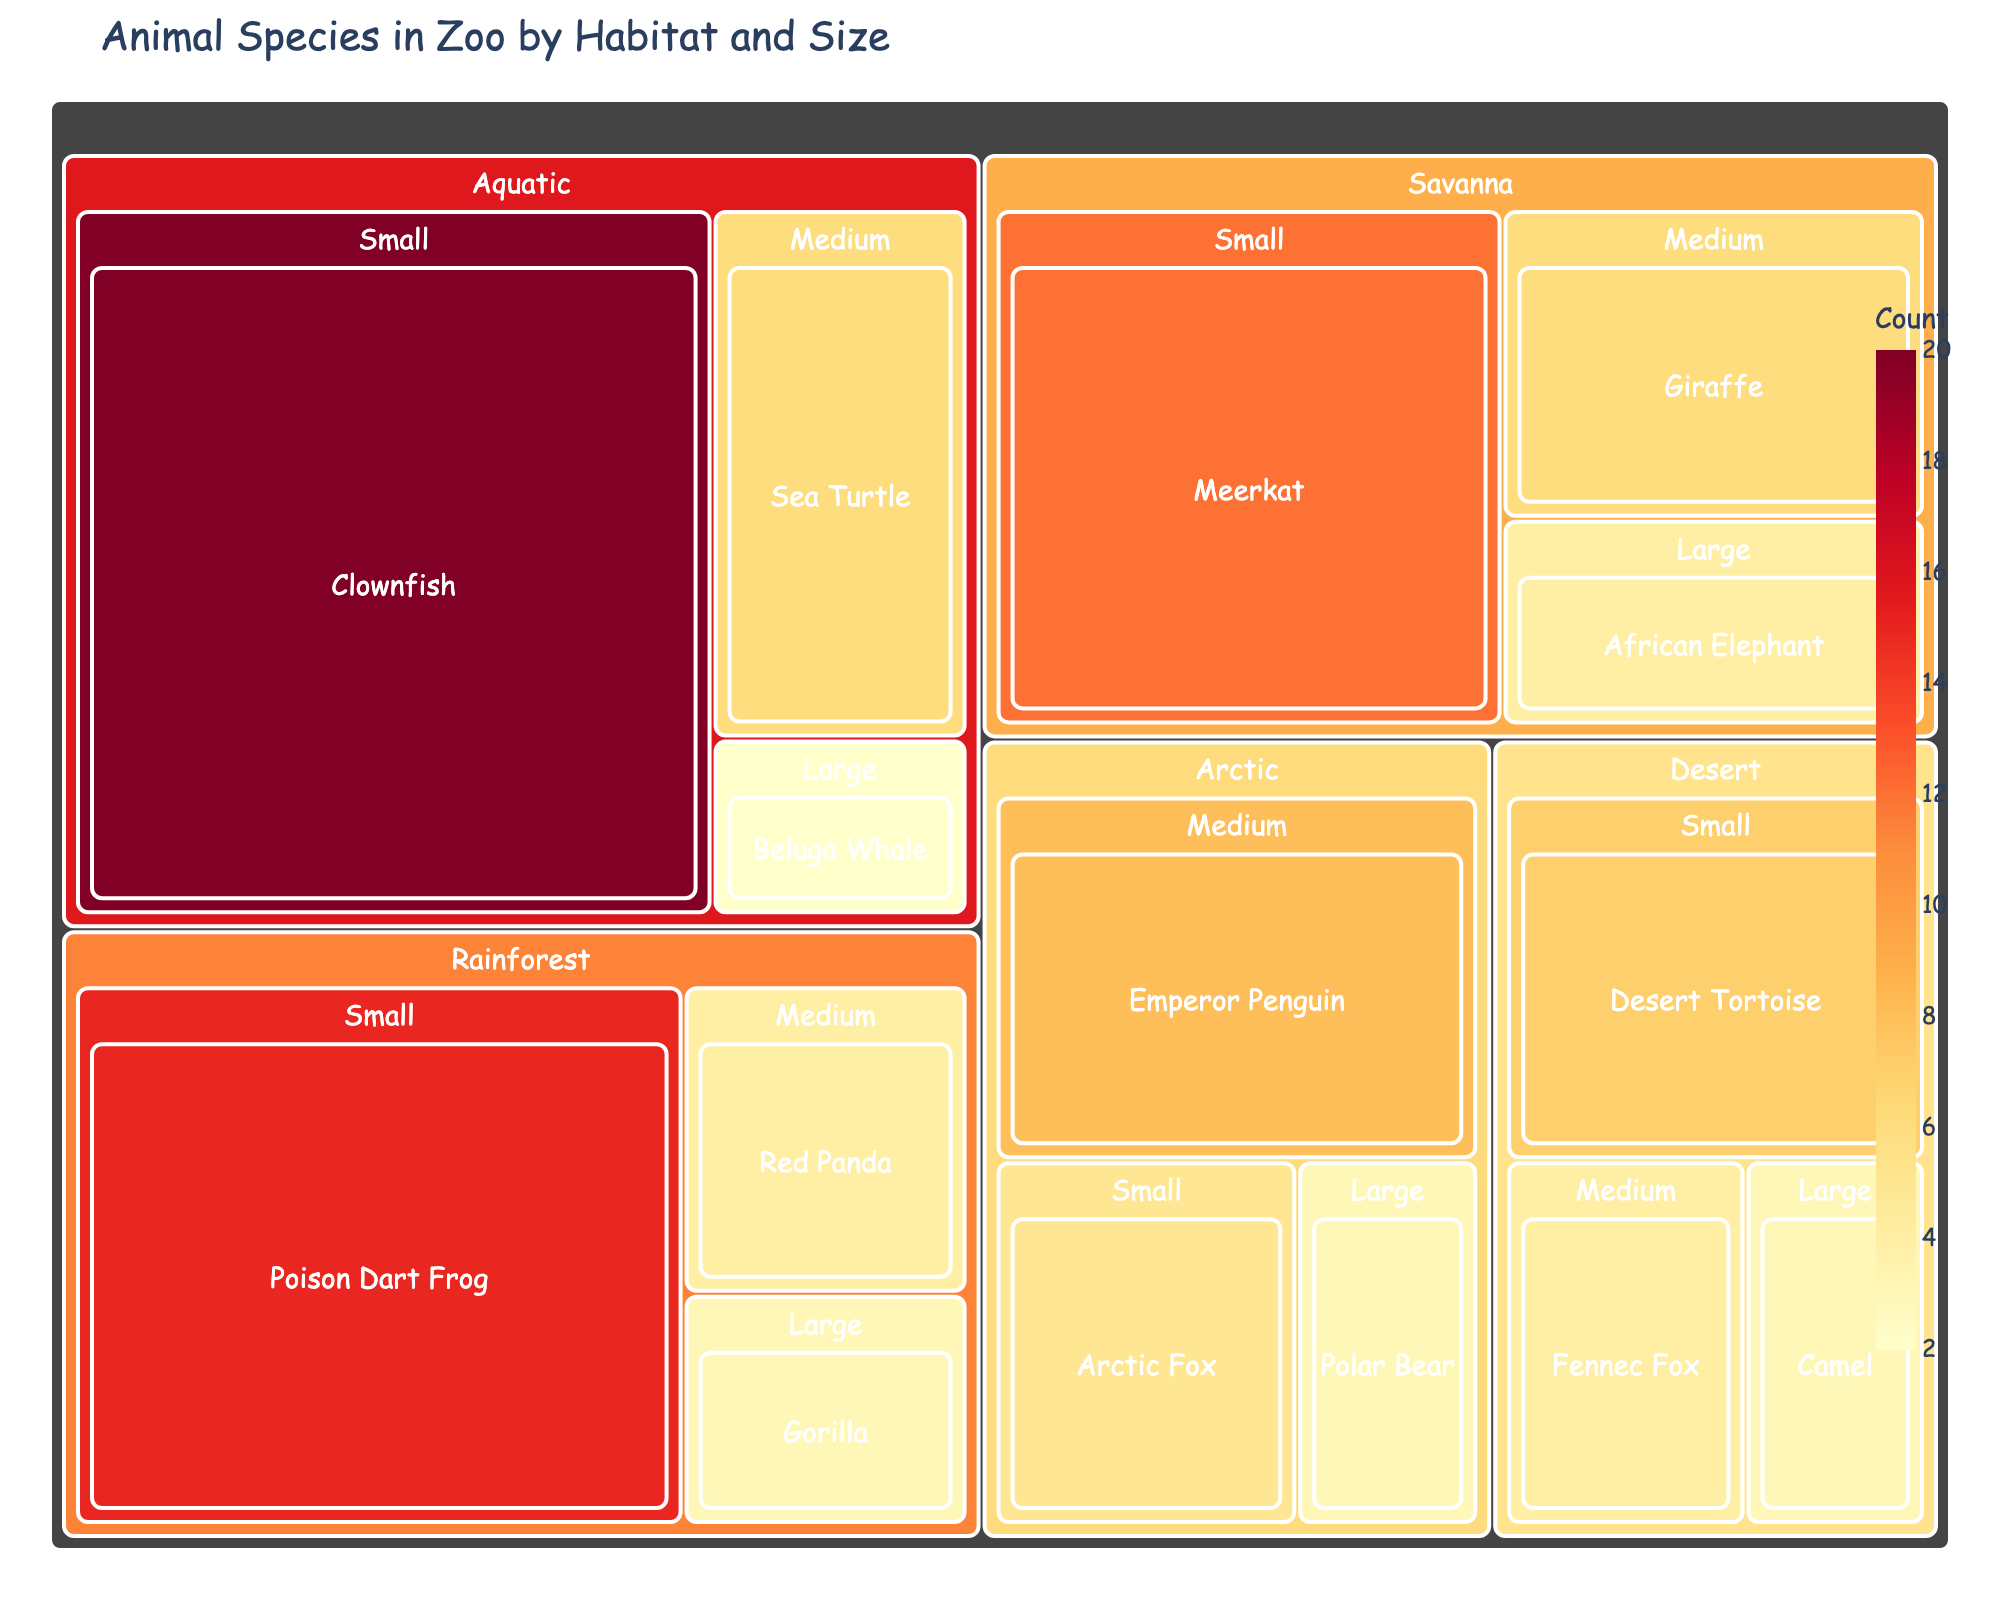what is the title of the figure? The title of the figure is displayed at the top of the treemap. It usually gives an overview of what the chart represents.
Answer: Animal Species in Zoo by Habitat and Size Which habitat has the most small animals? Look for the habitat category with the largest area or box in the "Small" section of the treemap.
Answer: Aquatic How many Emperor Penguins are in the zoo? Find the box labeled "Emperor Penguin" under the Arctic habitat. The count is shown on the box.
Answer: 8 Which habitat has the largest animal count overall? Add the counts of all animals within each habitat and compare. Aquatic: 28 (20+6+2), Savanna: 22 (12+6+4), Rainforest: 22 (15+4+3), Arctic: 16 (5+8+3), Desert: 14 (7+4+3)
Answer: Aquatic What's the difference in count between the animals in the Arctic and Desert habitats? Sum the counts in the Arctic habitat and the Desert habitat, then find the difference. Arctic: 16, Desert: 14. The difference is 16 - 14.
Answer: 2 Which habitat houses the smallest animal? Look for the smallest animals in each habitat and pick the one with the lowest count. All small animals except the Clownfish (20) have low counts, but the Clownfish has the smallest count among small animals.
Answer: Clownfish Which large animal has the smallest count? Among the large animals (count: Polar Bear 3, Gorilla 3, Beluga Whale 2, Camel 3, African Elephant 4), find the one with the smallest count.
Answer: Beluga Whale Are there more medium-sized animals in the Savanna or the Desert? Compare the number of animals in the medium size section for both Savanna and Desert. Savanna has 6, Desert has 4.
Answer: Savanna What's the total number of animals in the zoo? Sum all the counts of the animals in each category. 4+6+12+3+8+5+3+4+15+2+6+20+3+4+7 = 102
Answer: 102 Which animal category has the highest count within the Rainforest habitat? Within the Rainforest habitat, compare the counts of the animals (Gorilla 3, Red Panda 4, Poison Dart Frog 15) to find the highest.
Answer: Poison Dart Frog 